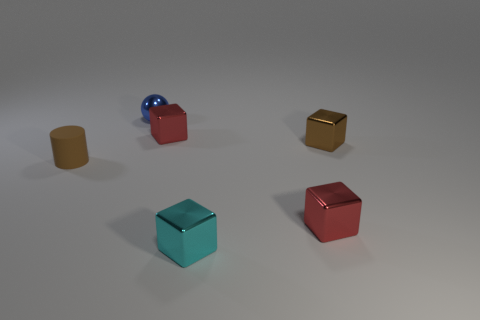Add 2 metallic balls. How many objects exist? 8 Subtract all balls. How many objects are left? 5 Add 2 rubber cylinders. How many rubber cylinders are left? 3 Add 2 tiny brown metal objects. How many tiny brown metal objects exist? 3 Subtract 1 blue spheres. How many objects are left? 5 Subtract all small matte cylinders. Subtract all tiny brown rubber cylinders. How many objects are left? 4 